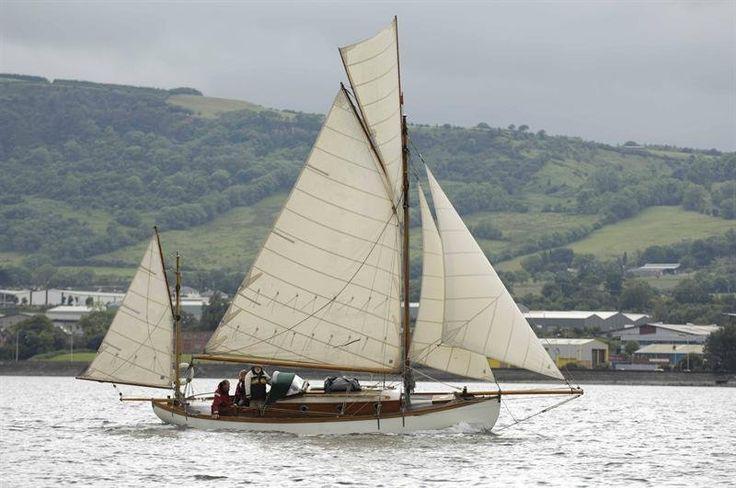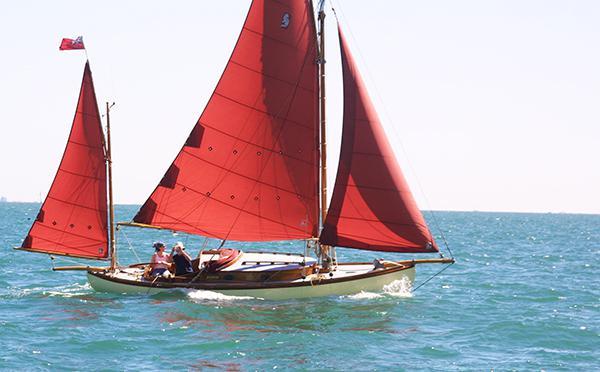The first image is the image on the left, the second image is the image on the right. Evaluate the accuracy of this statement regarding the images: "The sails on both boats are nearly the same color.". Is it true? Answer yes or no. No. The first image is the image on the left, the second image is the image on the right. Assess this claim about the two images: "An image shows a white-bodied boat with only reddish sails.". Correct or not? Answer yes or no. Yes. 